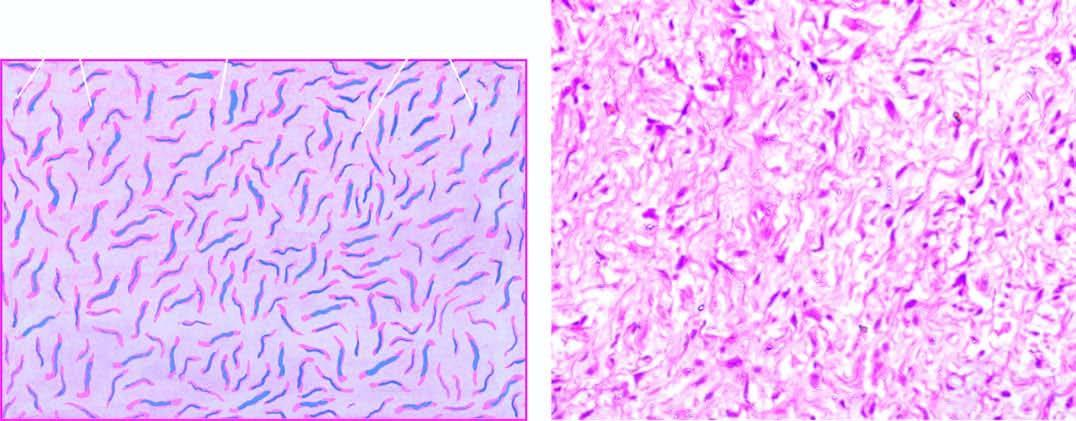what is separated by mucoid matrix?
Answer the question using a single word or phrase. Interlacing bundles of spindle-shaped cells 